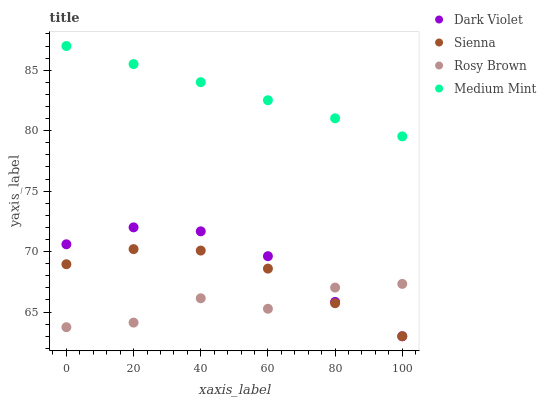Does Rosy Brown have the minimum area under the curve?
Answer yes or no. Yes. Does Medium Mint have the maximum area under the curve?
Answer yes or no. Yes. Does Medium Mint have the minimum area under the curve?
Answer yes or no. No. Does Rosy Brown have the maximum area under the curve?
Answer yes or no. No. Is Medium Mint the smoothest?
Answer yes or no. Yes. Is Rosy Brown the roughest?
Answer yes or no. Yes. Is Rosy Brown the smoothest?
Answer yes or no. No. Is Medium Mint the roughest?
Answer yes or no. No. Does Sienna have the lowest value?
Answer yes or no. Yes. Does Rosy Brown have the lowest value?
Answer yes or no. No. Does Medium Mint have the highest value?
Answer yes or no. Yes. Does Rosy Brown have the highest value?
Answer yes or no. No. Is Rosy Brown less than Medium Mint?
Answer yes or no. Yes. Is Medium Mint greater than Rosy Brown?
Answer yes or no. Yes. Does Dark Violet intersect Rosy Brown?
Answer yes or no. Yes. Is Dark Violet less than Rosy Brown?
Answer yes or no. No. Is Dark Violet greater than Rosy Brown?
Answer yes or no. No. Does Rosy Brown intersect Medium Mint?
Answer yes or no. No. 